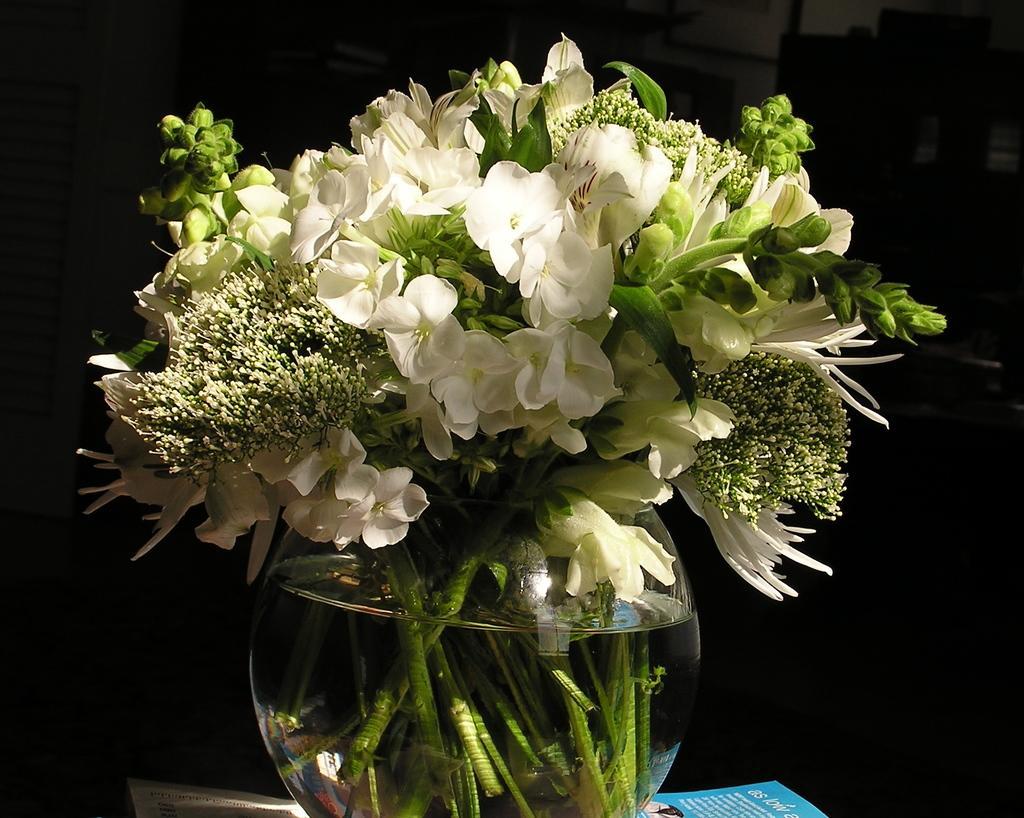Please provide a concise description of this image. In this image there are so many flowers on the glass pot on which we can see there is some water. 